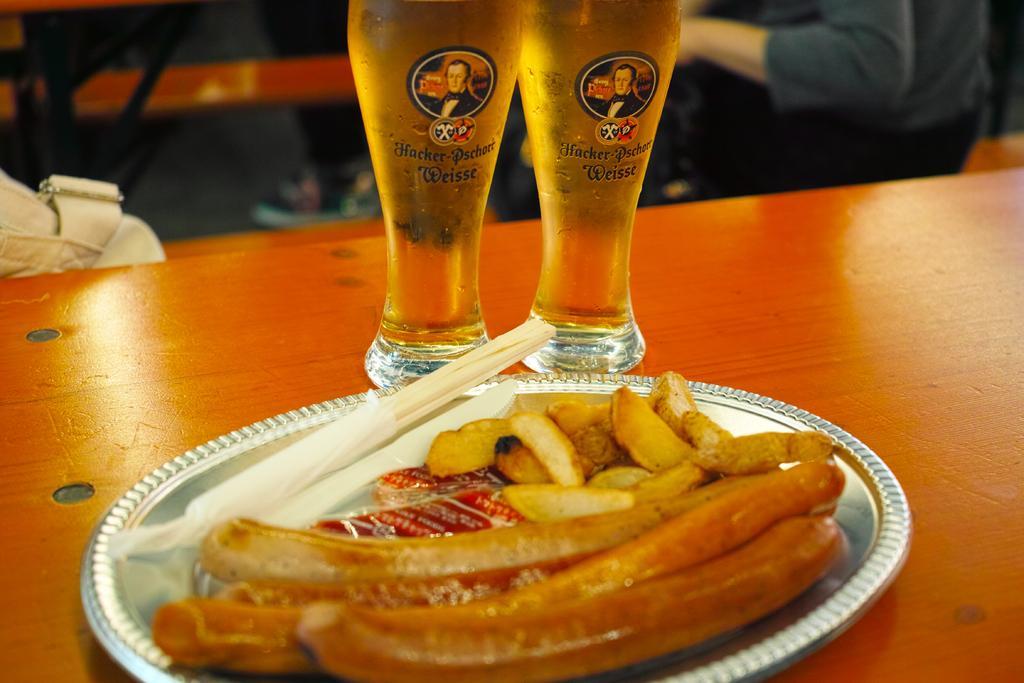In one or two sentences, can you explain what this image depicts? In this picture I can see food in the plate and I can see couple of glasses on the table and I can see a human in the back and a bag on the left side of the picture. 